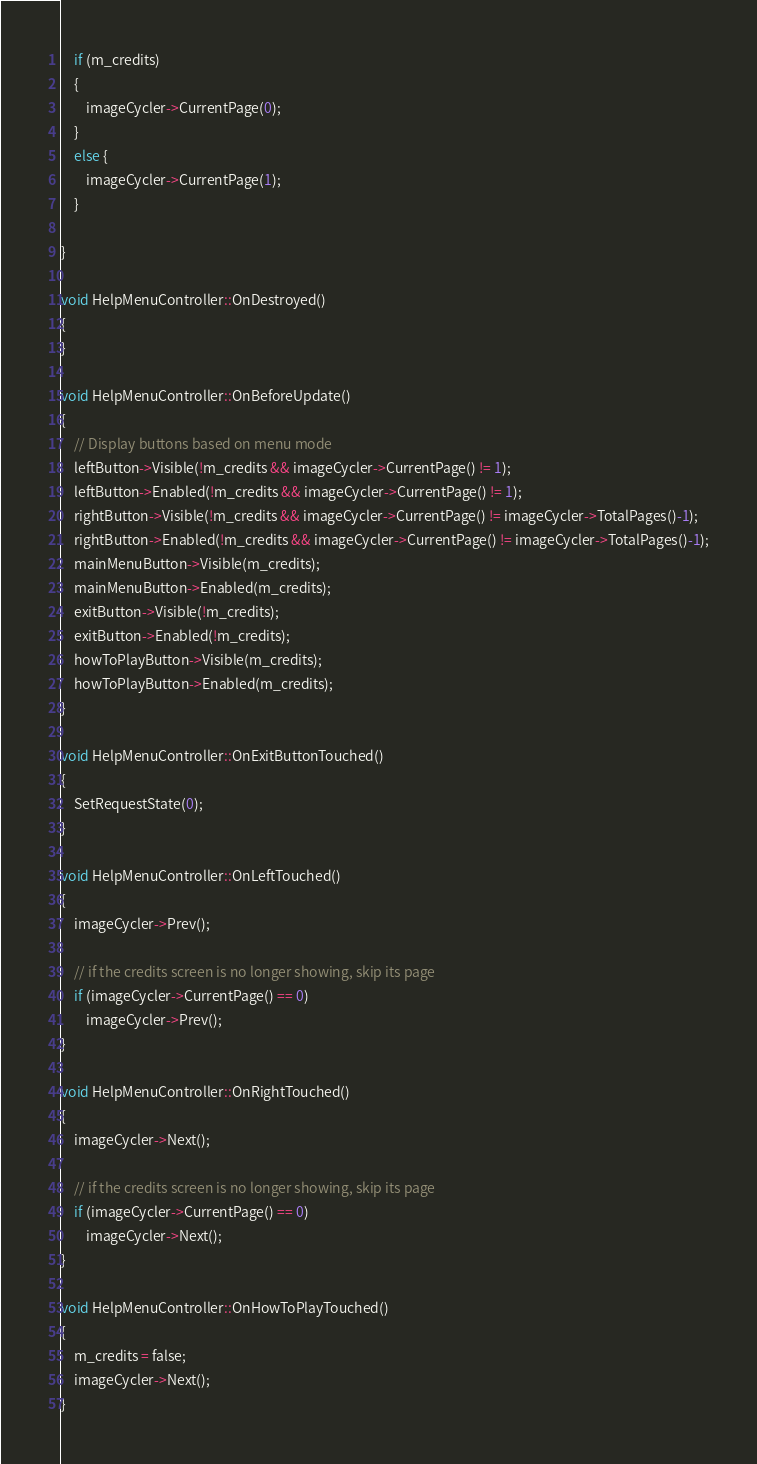Convert code to text. <code><loc_0><loc_0><loc_500><loc_500><_ObjectiveC_>	if (m_credits)
	{
		imageCycler->CurrentPage(0);
	}
	else {
		imageCycler->CurrentPage(1);
	}

}

void HelpMenuController::OnDestroyed()
{
}

void HelpMenuController::OnBeforeUpdate()
{		
	// Display buttons based on menu mode
	leftButton->Visible(!m_credits && imageCycler->CurrentPage() != 1);
	leftButton->Enabled(!m_credits && imageCycler->CurrentPage() != 1);
	rightButton->Visible(!m_credits && imageCycler->CurrentPage() != imageCycler->TotalPages()-1);
	rightButton->Enabled(!m_credits && imageCycler->CurrentPage() != imageCycler->TotalPages()-1);
	mainMenuButton->Visible(m_credits);
	mainMenuButton->Enabled(m_credits);
	exitButton->Visible(!m_credits);
	exitButton->Enabled(!m_credits);
	howToPlayButton->Visible(m_credits);
	howToPlayButton->Enabled(m_credits);
}

void HelpMenuController::OnExitButtonTouched()
{
	SetRequestState(0);
}

void HelpMenuController::OnLeftTouched()
{
	imageCycler->Prev();
	
	// if the credits screen is no longer showing, skip its page
	if (imageCycler->CurrentPage() == 0)
		imageCycler->Prev();
}

void HelpMenuController::OnRightTouched()
{
	imageCycler->Next();
	
	// if the credits screen is no longer showing, skip its page
	if (imageCycler->CurrentPage() == 0)
		imageCycler->Next();
}

void HelpMenuController::OnHowToPlayTouched()
{
	m_credits = false;
	imageCycler->Next();
}</code> 